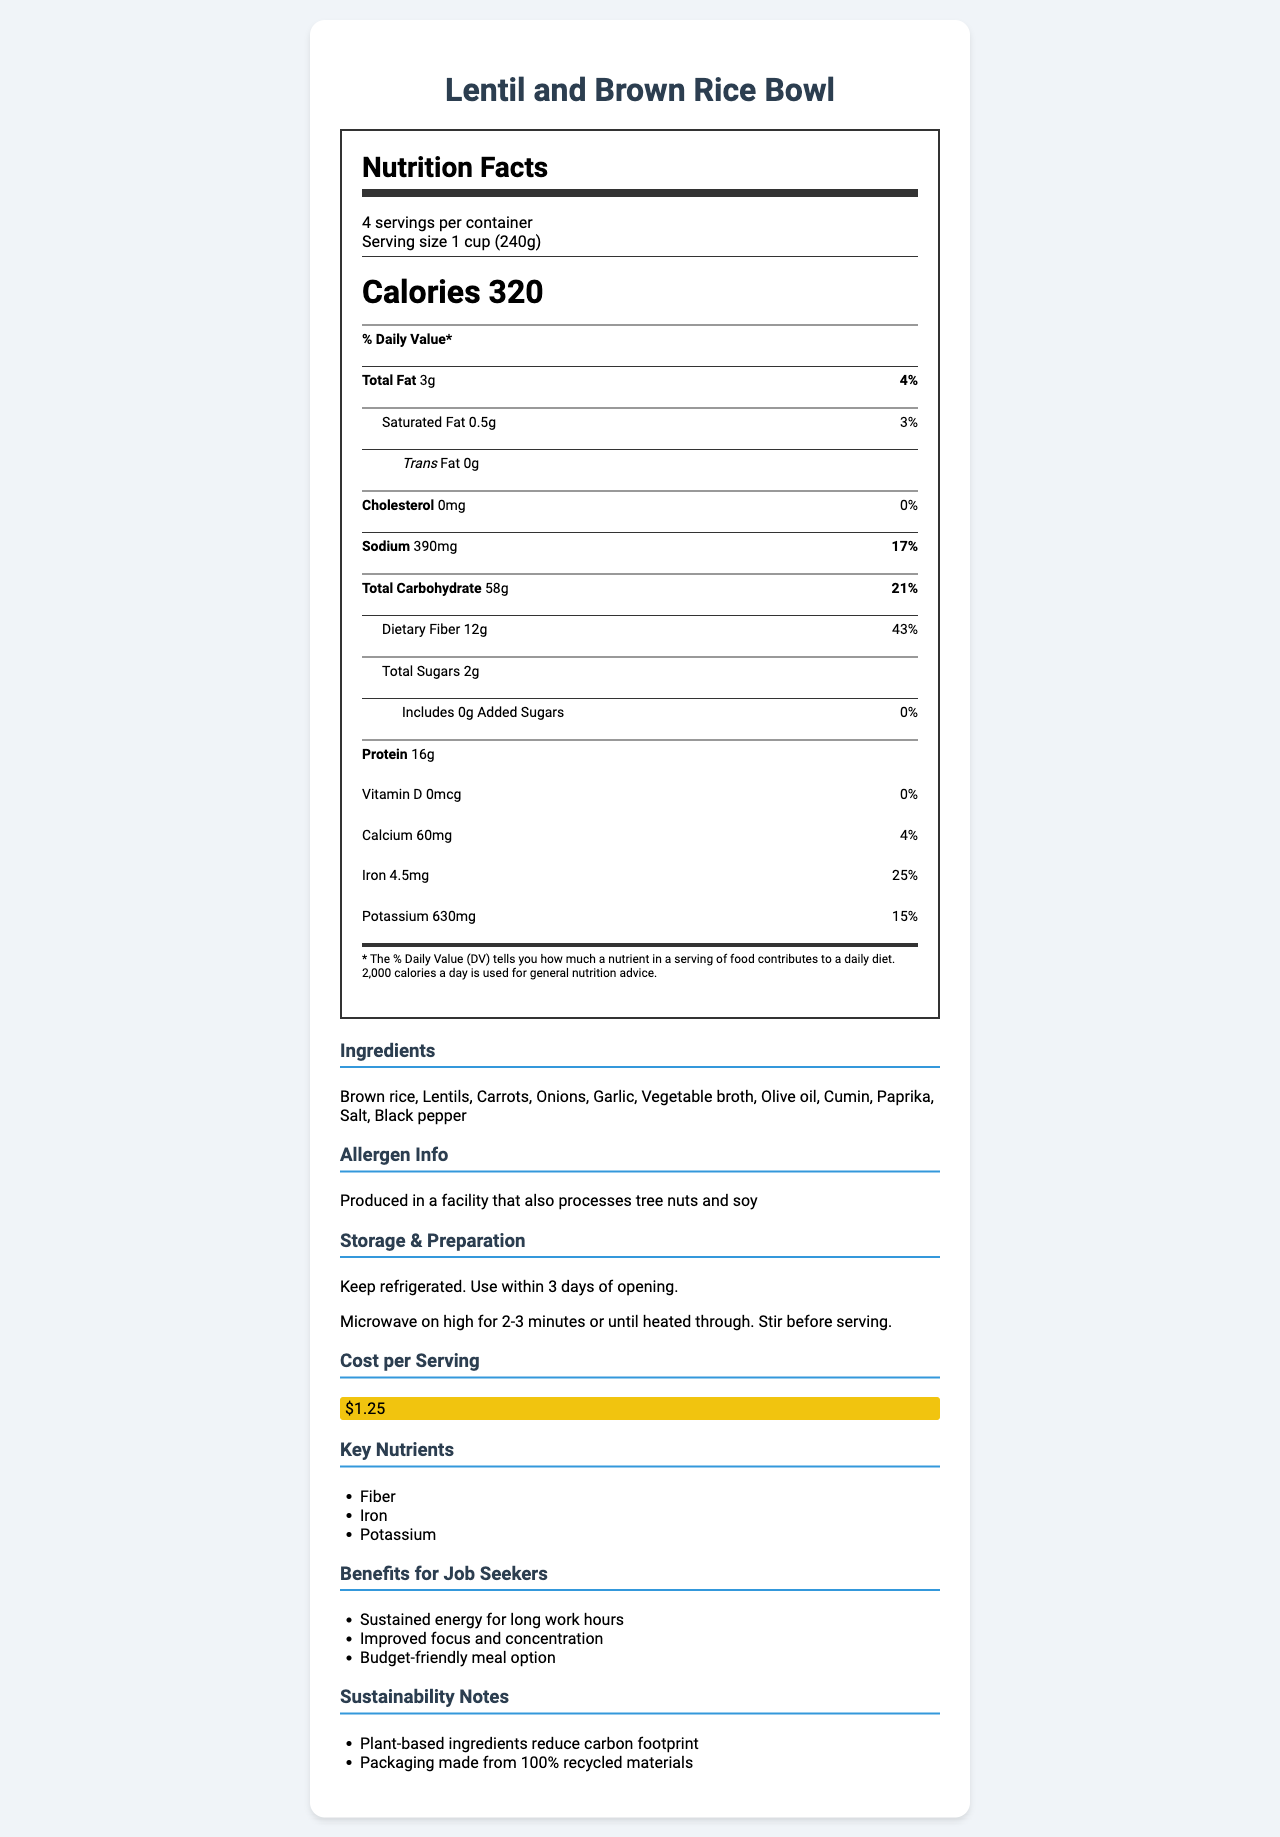what is the serving size? The serving size is clearly indicated in the document under the serving information section.
Answer: 1 cup (240g) how many calories are in one serving? The calories per serving are listed right beneath the serving size and servings per container information.
Answer: 320 what is the total fat content per serving? The total fat content is listed in the nutrition facts section under the bolded "Total Fat".
Answer: 3g what is the daily value percentage of sodium per serving? The daily value percentage for sodium is listed in the nutrition facts section next to the sodium amount.
Answer: 17% what are the main ingredients in this dish? The ingredients are listed in the additional information section under the "Ingredients" heading.
Answer: Brown rice, Lentils, Carrots, Onions, Garlic, Vegetable broth, Olive oil, Cumin, Paprika, Salt, Black pepper how much protein does one serving provide? The amount of protein per serving is listed in the nutrition facts section under the bolded "Protein".
Answer: 16g how many servings are there per container? The number of servings per container is listed right beneath the product name in the serving information section.
Answer: 4 what is the cost per serving? A. $1.00 B. $1.25 C. $1.50 D. $2.00 The cost per serving is listed in the additional information section under the "Cost per Serving" heading.
Answer: B how much dietary fiber is in one serving? The amount of dietary fiber per serving is listed in the nutrition facts section under the bolded "Dietary Fiber".
Answer: 12g which of the following is a benefit for job seekers? A. Reduced daily calorie intake B. Enhanced taste and flavor C. Improved focus and concentration D. Increased sugar levels The benefits for job seekers are listed in the additional information section under "Benefits for Job Seekers".
Answer: C is this dish high in sodium? The daily value percentage for sodium is 17%, which can be considered high for certain dietary needs.
Answer: Yes what are some key nutrients in this dish? The key nutrients are listed under the "Key Nutrients" heading in the additional information section.
Answer: Fiber, Iron, Potassium is this dish suitable for individuals with tree nut allergies? The allergen information in the document indicates that it is produced in a facility that also processes tree nuts.
Answer: No describe the main idea of this document. The document focuses on presenting comprehensive dietary information and practical data for ensuring the dish is beneficial, cost-effective, and easy to prepare, especially for job training participants.
Answer: The document provides detailed nutritional information, ingredients, allergen info, storage and preparation instructions, cost per serving, and benefits for job seekers for a high-protein, low-cost vegetarian dish, the "Lentil and Brown Rice Bowl". It highlights the health benefits, sustainability notes, and aims to help underprivileged individuals by offering a budget-friendly meal option. how much Calcium does one serving provide? The amount of Calcium per serving is listed under the nutrition facts section.
Answer: 60mg what is the daily value percentage of Iron per serving? The daily value percentage for Iron is listed next to the Iron amount in the nutrition facts section.
Answer: 25% how long can the dish be stored after opening? The storage instructions are provided in the additional information section and indicate to use within 3 days of opening.
Answer: 3 days what are the protein sources in this dish? The protein sources are listed in the additional information section under "Protein Sources".
Answer: Lentils, Brown rice how do you prepare this dish? The preparation instructions are listed in the additional information section under "Storage & Preparation".
Answer: Microwave on high for 2-3 minutes or until heated through. Stir before serving. which ingredient is not listed in the ingredients section? A. Carrots B. Peas C. Garlic D. Olive oil The ingredients section does not list peas; the other options are included in the ingredients list.
Answer: B can this dish be considered sustainable? The sustainability notes indicate that plant-based ingredients reduce the carbon footprint and the packaging is made from 100% recycled materials.
Answer: Yes 